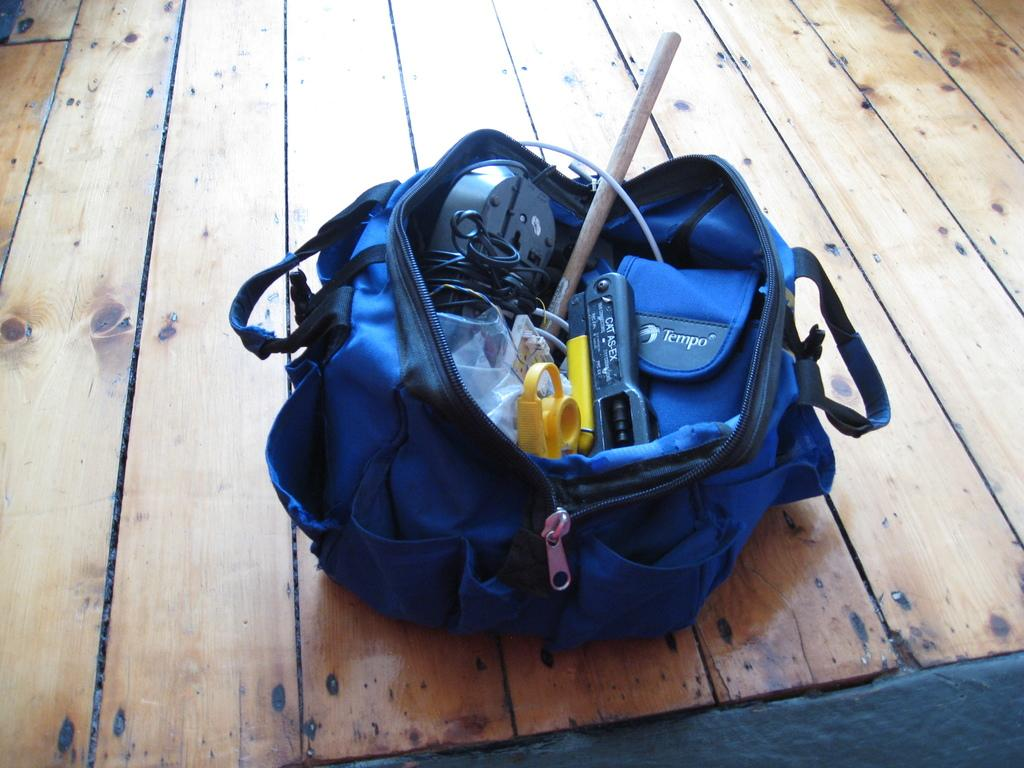What color is the bag that is visible in the image? The bag is blue colored. What is inside the bag that is visible in the image? There are objects inside the blue colored bag. Where is the bag located in the image? The bag is in the middle of the image. What type of flooring can be seen in the background of the image? There is a wooden floor in the background of the image. Can you hear the bell ringing in the image? There is no bell present in the image, so it cannot be heard. 